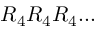Convert formula to latex. <formula><loc_0><loc_0><loc_500><loc_500>R _ { 4 } R _ { 4 } R _ { 4 } \dots</formula> 